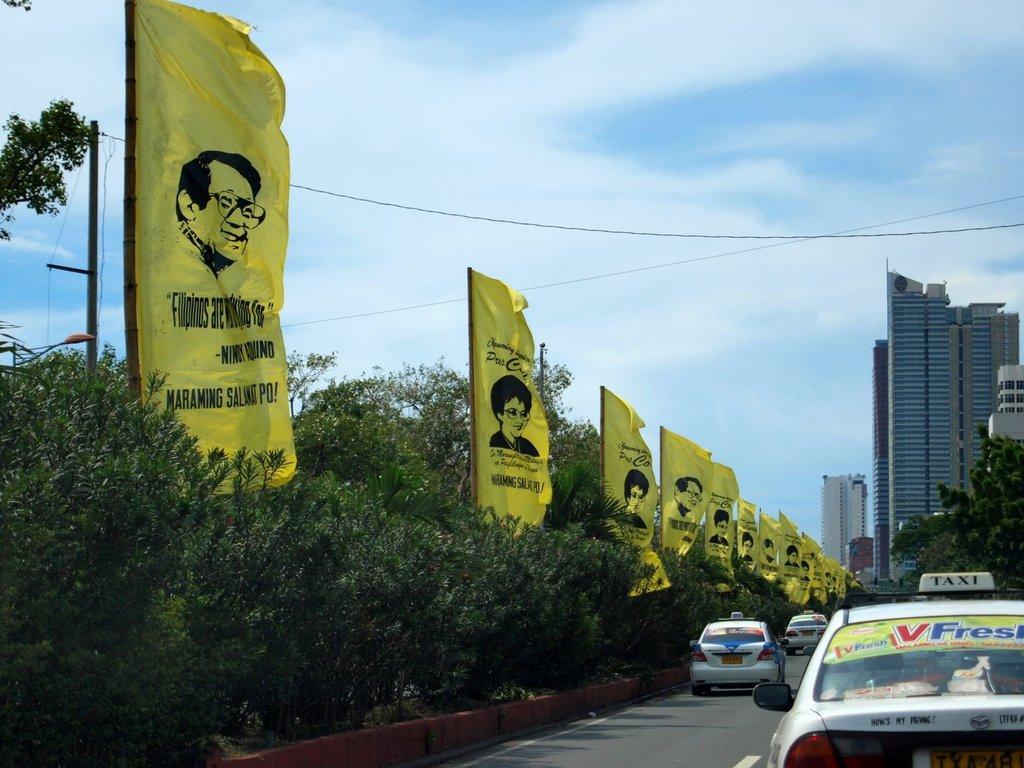What does the car say on the top?
Provide a short and direct response. Taxi. What is the first word of the quote on the closest yellow sign?
Ensure brevity in your answer.  Filipinos. 